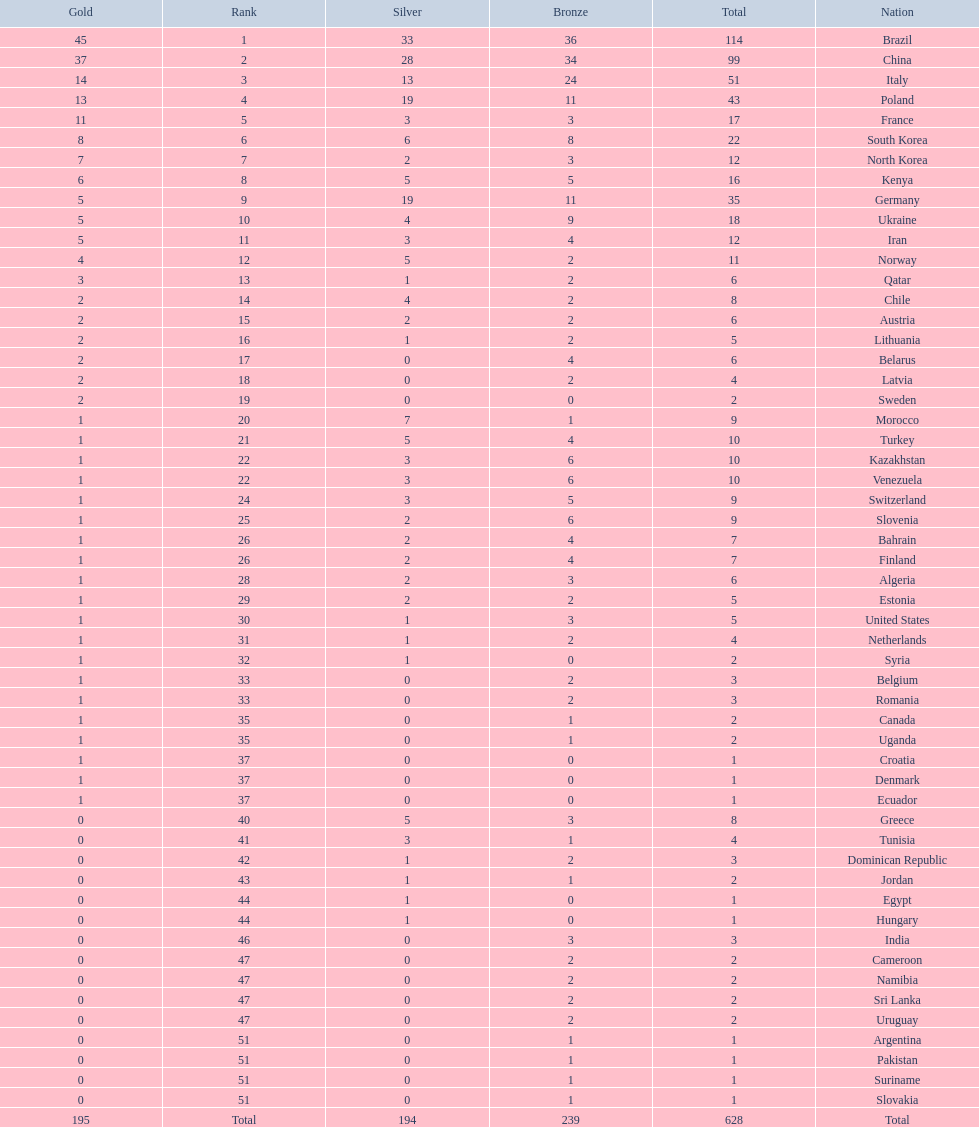How many more gold medals does china have over france? 26. 